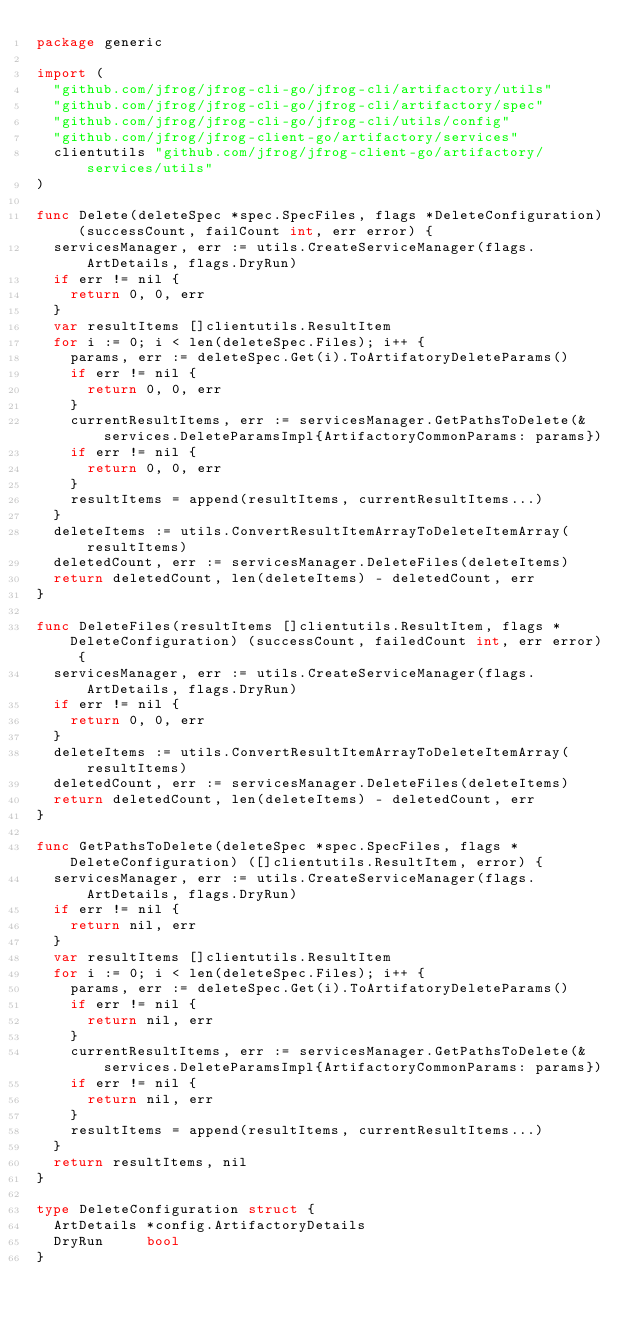Convert code to text. <code><loc_0><loc_0><loc_500><loc_500><_Go_>package generic

import (
	"github.com/jfrog/jfrog-cli-go/jfrog-cli/artifactory/utils"
	"github.com/jfrog/jfrog-cli-go/jfrog-cli/artifactory/spec"
	"github.com/jfrog/jfrog-cli-go/jfrog-cli/utils/config"
	"github.com/jfrog/jfrog-client-go/artifactory/services"
	clientutils "github.com/jfrog/jfrog-client-go/artifactory/services/utils"
)

func Delete(deleteSpec *spec.SpecFiles, flags *DeleteConfiguration) (successCount, failCount int, err error) {
	servicesManager, err := utils.CreateServiceManager(flags.ArtDetails, flags.DryRun)
	if err != nil {
		return 0, 0, err
	}
	var resultItems []clientutils.ResultItem
	for i := 0; i < len(deleteSpec.Files); i++ {
		params, err := deleteSpec.Get(i).ToArtifatoryDeleteParams()
		if err != nil {
			return 0, 0, err
		}
		currentResultItems, err := servicesManager.GetPathsToDelete(&services.DeleteParamsImpl{ArtifactoryCommonParams: params})
		if err != nil {
			return 0, 0, err
		}
		resultItems = append(resultItems, currentResultItems...)
	}
	deleteItems := utils.ConvertResultItemArrayToDeleteItemArray(resultItems)
	deletedCount, err := servicesManager.DeleteFiles(deleteItems)
	return deletedCount, len(deleteItems) - deletedCount, err
}

func DeleteFiles(resultItems []clientutils.ResultItem, flags *DeleteConfiguration) (successCount, failedCount int, err error) {
	servicesManager, err := utils.CreateServiceManager(flags.ArtDetails, flags.DryRun)
	if err != nil {
		return 0, 0, err
	}
	deleteItems := utils.ConvertResultItemArrayToDeleteItemArray(resultItems)
	deletedCount, err := servicesManager.DeleteFiles(deleteItems)
	return deletedCount, len(deleteItems) - deletedCount, err
}

func GetPathsToDelete(deleteSpec *spec.SpecFiles, flags *DeleteConfiguration) ([]clientutils.ResultItem, error) {
	servicesManager, err := utils.CreateServiceManager(flags.ArtDetails, flags.DryRun)
	if err != nil {
		return nil, err
	}
	var resultItems []clientutils.ResultItem
	for i := 0; i < len(deleteSpec.Files); i++ {
		params, err := deleteSpec.Get(i).ToArtifatoryDeleteParams()
		if err != nil {
			return nil, err
		}
		currentResultItems, err := servicesManager.GetPathsToDelete(&services.DeleteParamsImpl{ArtifactoryCommonParams: params})
		if err != nil {
			return nil, err
		}
		resultItems = append(resultItems, currentResultItems...)
	}
	return resultItems, nil
}

type DeleteConfiguration struct {
	ArtDetails *config.ArtifactoryDetails
	DryRun     bool
}
</code> 